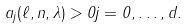Convert formula to latex. <formula><loc_0><loc_0><loc_500><loc_500>a _ { j } ( \ell , n , \lambda ) > 0 j = 0 , \dots , d .</formula> 